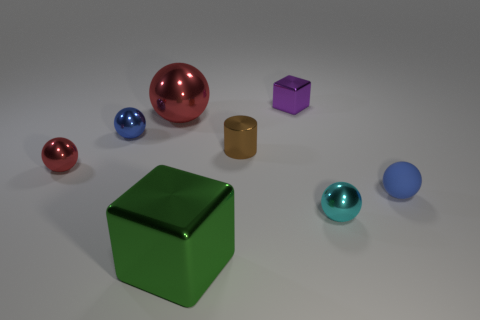Subtract all cyan spheres. How many spheres are left? 4 Subtract all tiny cyan spheres. How many spheres are left? 4 Subtract all gray balls. Subtract all red cylinders. How many balls are left? 5 Add 1 large red metal things. How many objects exist? 9 Subtract all cylinders. How many objects are left? 7 Add 1 blue metal things. How many blue metal things are left? 2 Add 4 large green metallic objects. How many large green metallic objects exist? 5 Subtract 2 blue spheres. How many objects are left? 6 Subtract all large blue shiny cylinders. Subtract all big red metal things. How many objects are left? 7 